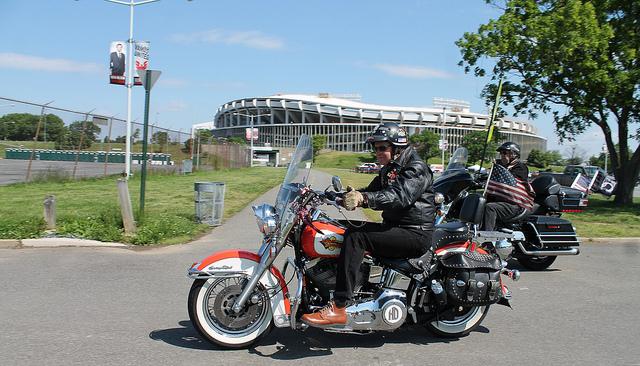How many wheels are on the ground?
Quick response, please. 4. What country's flag is flying on the motorcycle?
Short answer required. Usa. What color are the man's shoes?
Write a very short answer. Brown. Is there only one biker??
Quick response, please. No. Where is the black bike?
Write a very short answer. Behind orange 1. Is the motorcycle on a city or rural road?
Write a very short answer. City. Is this safe?
Give a very brief answer. Yes. Are they both riding bikes?
Answer briefly. Yes. 